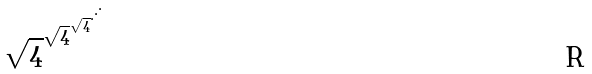<formula> <loc_0><loc_0><loc_500><loc_500>\sqrt { 4 } ^ { \sqrt { 4 } ^ { \sqrt { 4 } ^ { \cdot ^ { \cdot ^ { \cdot } } } } }</formula> 